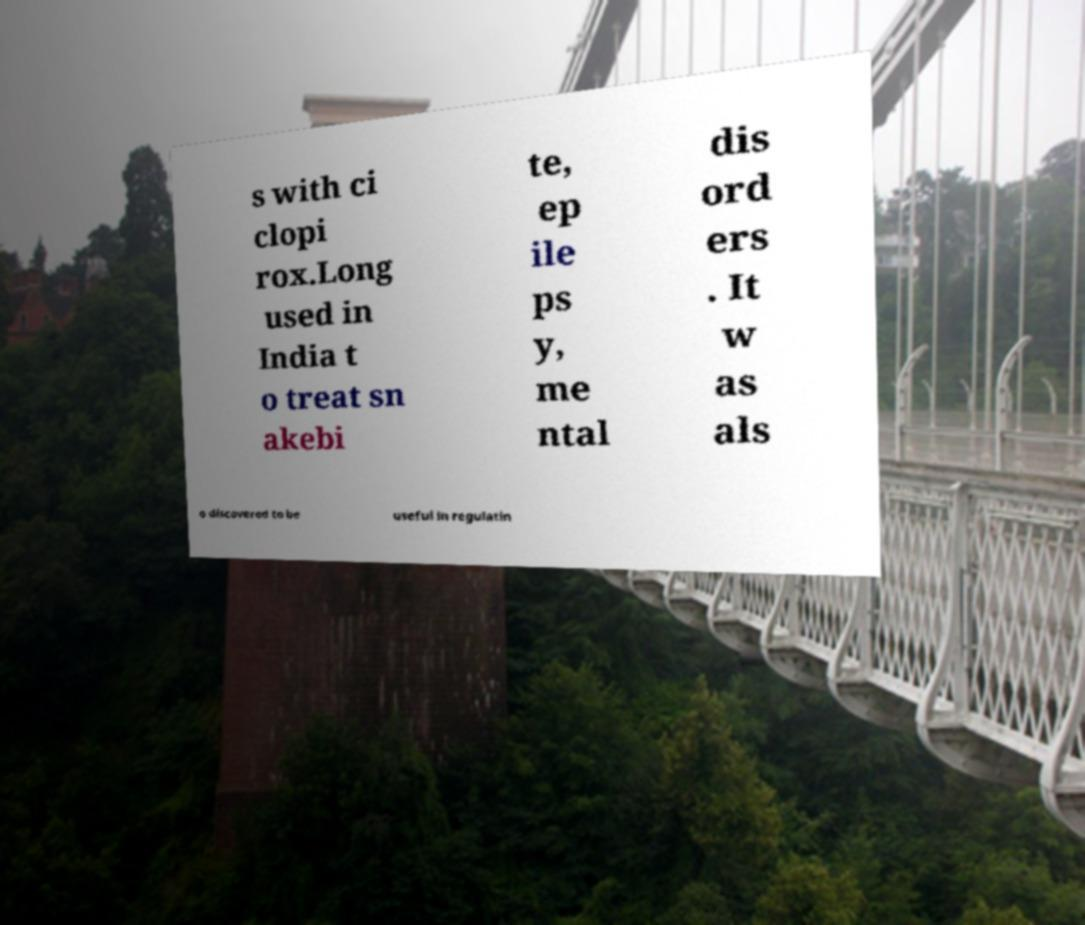Can you accurately transcribe the text from the provided image for me? s with ci clopi rox.Long used in India t o treat sn akebi te, ep ile ps y, me ntal dis ord ers . It w as als o discovered to be useful in regulatin 